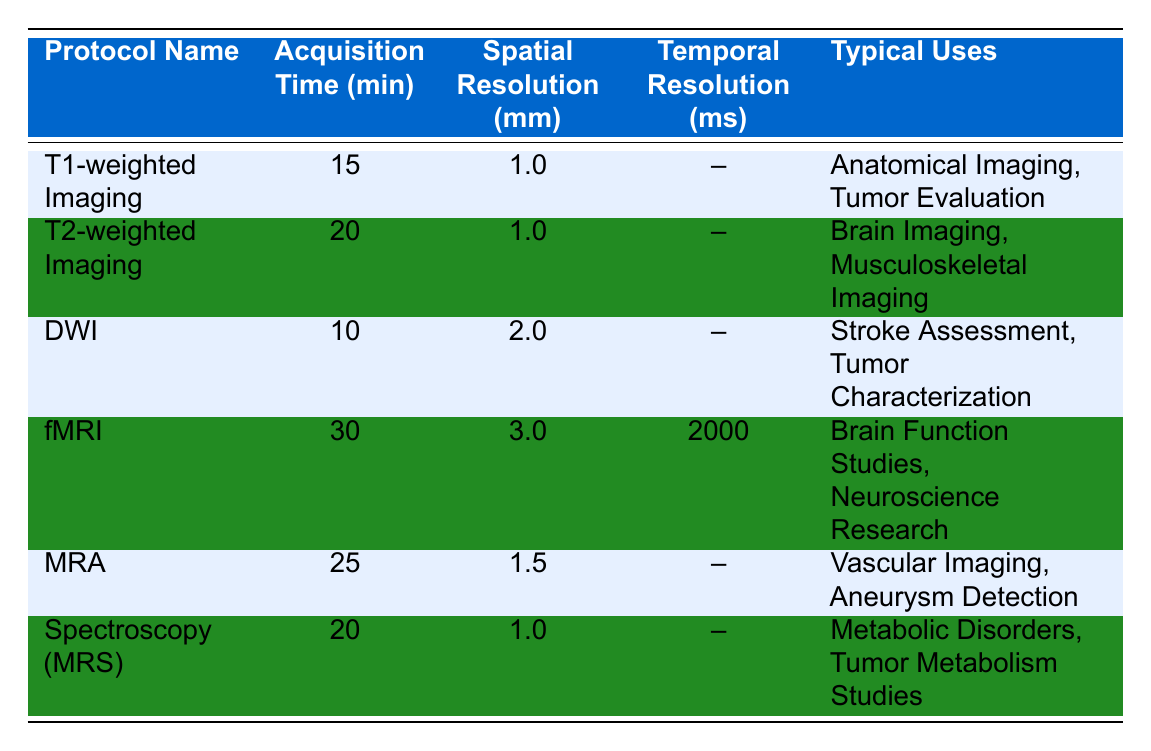What is the acquisition time of DWI (Diffusion Weighted Imaging)? According to the table, the acquisition time for DWI is explicitly listed as 10 minutes.
Answer: 10 minutes Which MRI protocol has the highest spatial resolution? The table shows that T1-weighted Imaging and T2-weighted Imaging both have a spatial resolution of 1.0 mm, which is the highest among all protocols listed.
Answer: T1-weighted Imaging and T2-weighted Imaging What is the average acquisition time for all listed MRI protocols? The acquisition times are 15, 20, 10, 30, 25, and 20 minutes. Adding these gives 15 + 20 + 10 + 30 + 25 + 20 = 130 minutes. There are 6 protocols, so the average is 130/6 = 21.67 minutes.
Answer: 21.67 minutes Is the temporal resolution for fMRI (Functional MRI) greater than 1000 ms? The table states that the temporal resolution for fMRI is 2000 ms. Since 2000 ms is greater than 1000 ms, the statement is true.
Answer: Yes Which protocol is used for Stroke Assessment? According to the table, DWI (Diffusion Weighted Imaging) is listed under typical uses for Stroke Assessment.
Answer: DWI (Diffusion Weighted Imaging) What is the total acquisition time for T2-weighted Imaging and MRA? The acquisition times for these protocols are 20 minutes for T2-weighted Imaging and 25 minutes for MRA. Adding these gives 20 + 25 = 45 minutes.
Answer: 45 minutes Are there any MRI protocols listed that have a temporal resolution? Only fMRI (Functional MRI) has a listed temporal resolution of 2000 ms, while the other protocols show '--' for temporal resolution, implying none of them have it explicitly defined. Therefore, the answer is no.
Answer: No Which protocol has a typical use related to Tumor Evaluation? The table indicates that both T1-weighted Imaging and Spectroscopy (MRS) have typical uses that include Tumor Evaluation, based on their descriptions in the typical uses column.
Answer: T1-weighted Imaging and Spectroscopy (MRS) What is the difference in acquisition time between fMRI and DWI? The acquisition time for fMRI is 30 minutes and for DWI, it is 10 minutes. Therefore, the difference is 30 - 10 = 20 minutes.
Answer: 20 minutes 